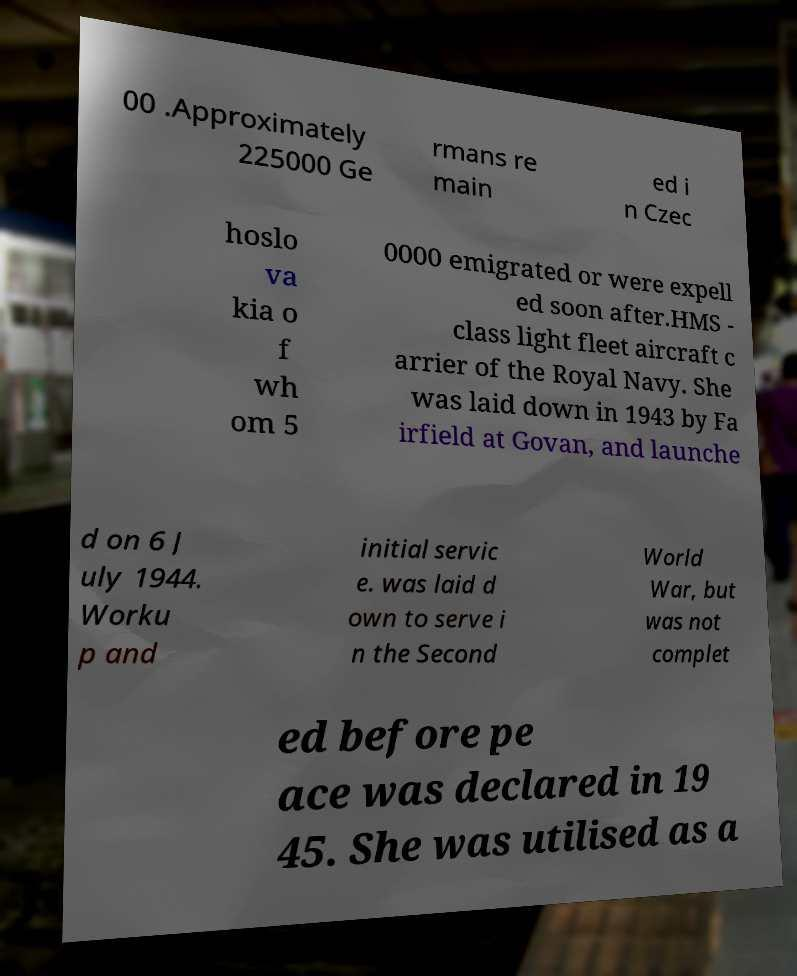What messages or text are displayed in this image? I need them in a readable, typed format. 00 .Approximately 225000 Ge rmans re main ed i n Czec hoslo va kia o f wh om 5 0000 emigrated or were expell ed soon after.HMS - class light fleet aircraft c arrier of the Royal Navy. She was laid down in 1943 by Fa irfield at Govan, and launche d on 6 J uly 1944. Worku p and initial servic e. was laid d own to serve i n the Second World War, but was not complet ed before pe ace was declared in 19 45. She was utilised as a 